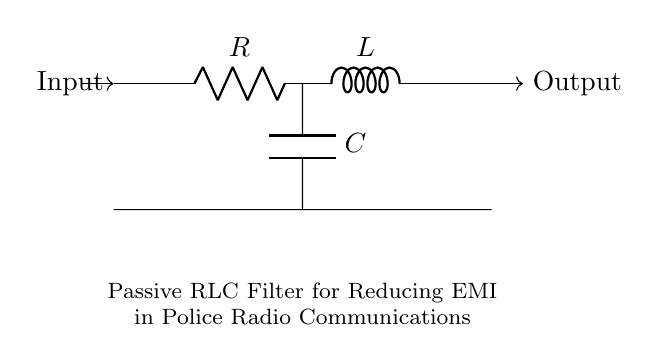What type of filter is depicted in the circuit? The circuit is a passive RLC filter, which is specifically designed to reduce electromagnetic interference (EMI) and is composed of a resistor (R), inductor (L), and capacitor (C).
Answer: passive RLC filter What components are present in the circuit? The circuit contains three main components: a resistor, an inductor, and a capacitor, each identified by their respective symbols.
Answer: resistor, inductor, capacitor Where is the input signal applied in the circuit? The input signal is applied at the left side of the circuit, as indicated by the arrow pointing towards the circuit.
Answer: left side What is the purpose of this RLC circuit in the context provided? The main purpose of the RLC circuit is to reduce electromagnetic interference in police radio communications, ensuring clearer signals by filtering out unwanted frequencies.
Answer: reduce EMI What is the relationship between the resistor, inductor, and capacitor in this filter? In a passive RLC filter, the resistor provides damping, the inductor allows low-frequency signals to pass while blocking high-frequency ones, and the capacitor does the opposite by allowing high-frequency signals to ground, effectively filtering the input signal.
Answer: damping, low-frequency, high-frequency What type of filter behavior does this configuration typically exhibit? This RLC configuration can exhibit a bandpass or bandstop behavior depending on the arrangement of the components, determining which frequencies are allowed through or attenuated.
Answer: bandpass or bandstop What electrical characteristic can this circuit help to improve for radio signals? By reducing EMI, this circuit helps to improve the signal-to-noise ratio for police communications, resulting in clearer signals and more reliable transmissions.
Answer: signal-to-noise ratio 